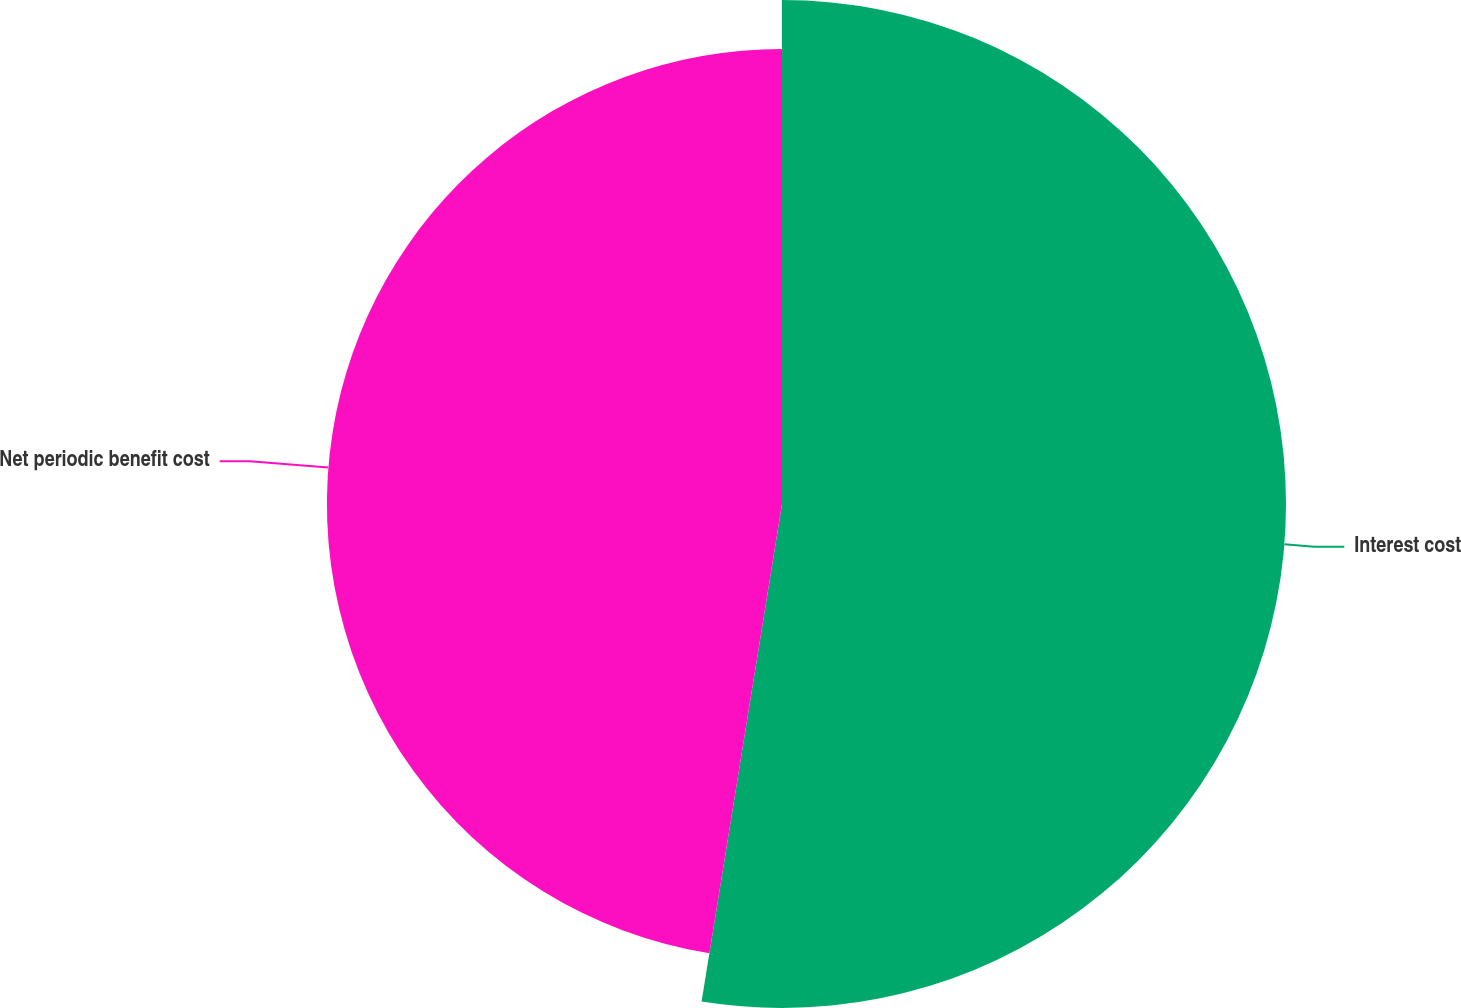Convert chart. <chart><loc_0><loc_0><loc_500><loc_500><pie_chart><fcel>Interest cost<fcel>Net periodic benefit cost<nl><fcel>52.55%<fcel>47.45%<nl></chart> 